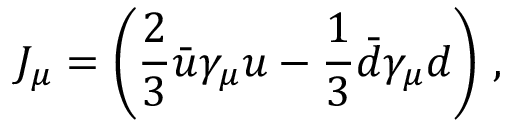Convert formula to latex. <formula><loc_0><loc_0><loc_500><loc_500>J _ { \mu } = \left ( \frac { 2 } 3 } \bar { u } \gamma _ { \mu } u - \frac { 1 } 3 } \bar { d } \gamma _ { \mu } d \right ) \, ,</formula> 